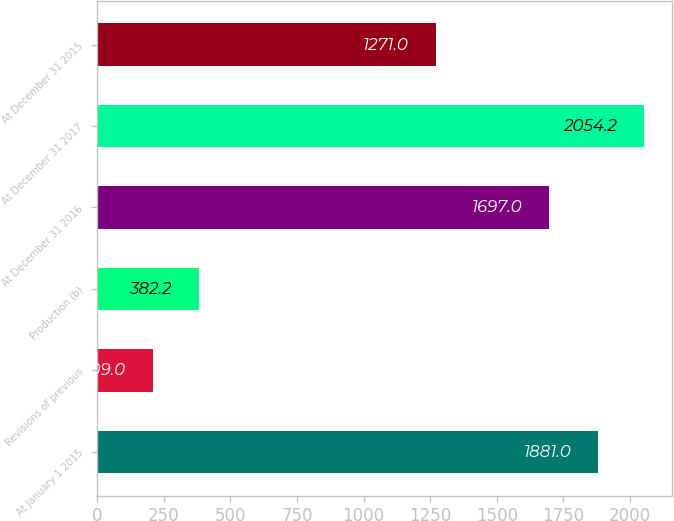Convert chart to OTSL. <chart><loc_0><loc_0><loc_500><loc_500><bar_chart><fcel>At January 1 2015<fcel>Revisions of previous<fcel>Production (b)<fcel>At December 31 2016<fcel>At December 31 2017<fcel>At December 31 2015<nl><fcel>1881<fcel>209<fcel>382.2<fcel>1697<fcel>2054.2<fcel>1271<nl></chart> 